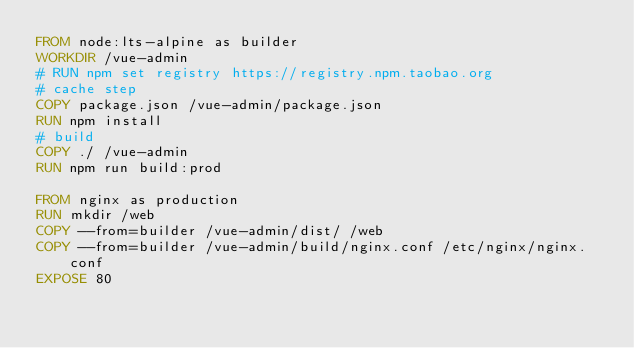Convert code to text. <code><loc_0><loc_0><loc_500><loc_500><_Dockerfile_>FROM node:lts-alpine as builder
WORKDIR /vue-admin
# RUN npm set registry https://registry.npm.taobao.org
# cache step
COPY package.json /vue-admin/package.json
RUN npm install
# build
COPY ./ /vue-admin
RUN npm run build:prod

FROM nginx as production
RUN mkdir /web
COPY --from=builder /vue-admin/dist/ /web
COPY --from=builder /vue-admin/build/nginx.conf /etc/nginx/nginx.conf
EXPOSE 80
</code> 